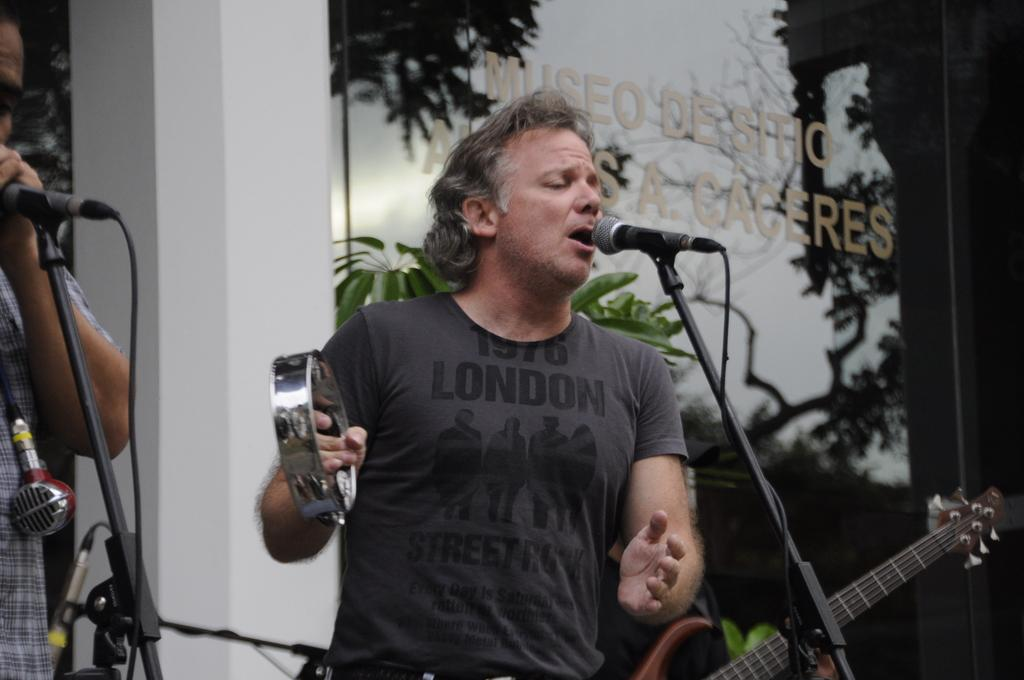How many people are in the image? There are two men in the image. What are the men doing in the image? The men are singing in the image. What object is present for amplifying their voices? There is a microphone in the image. What is one of the men holding in the image? One of the men is holding a musical instrument. What can be seen in the background of the image? There is a plant and a glass in the background of the image. What type of food is being divided among the two men in the image? There is no food present in the image, and the men are not dividing anything. 